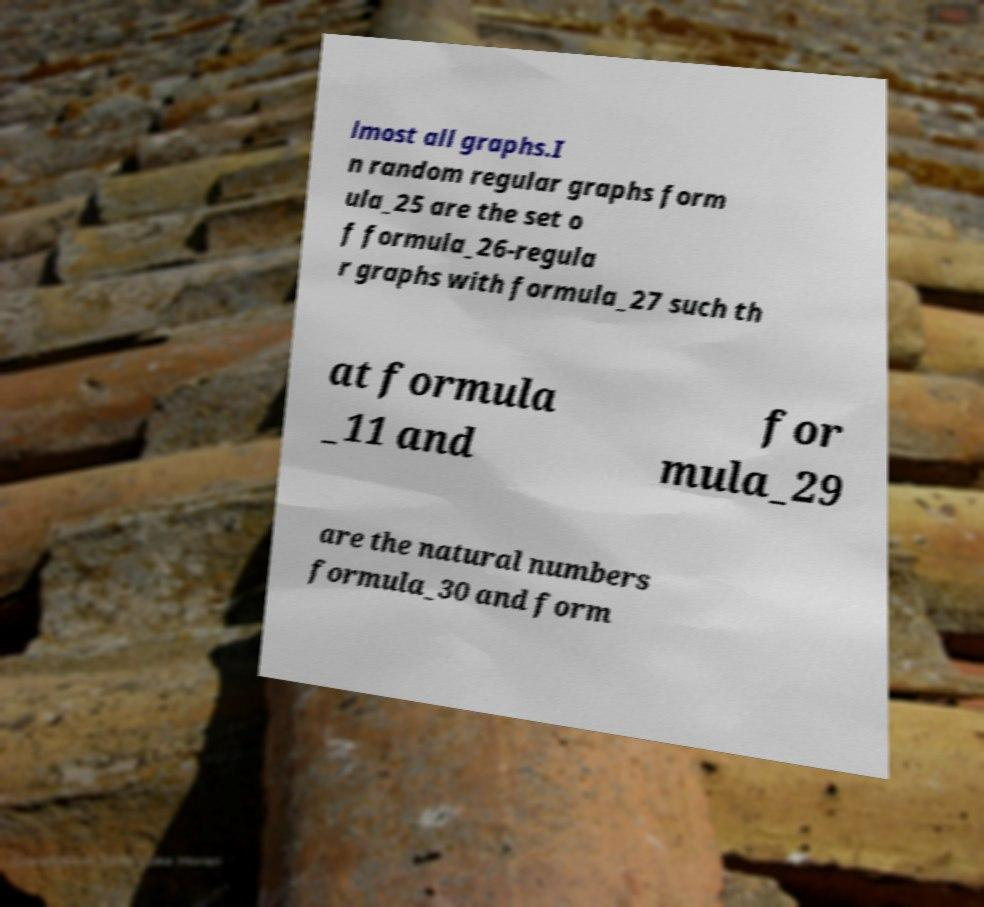For documentation purposes, I need the text within this image transcribed. Could you provide that? lmost all graphs.I n random regular graphs form ula_25 are the set o f formula_26-regula r graphs with formula_27 such th at formula _11 and for mula_29 are the natural numbers formula_30 and form 